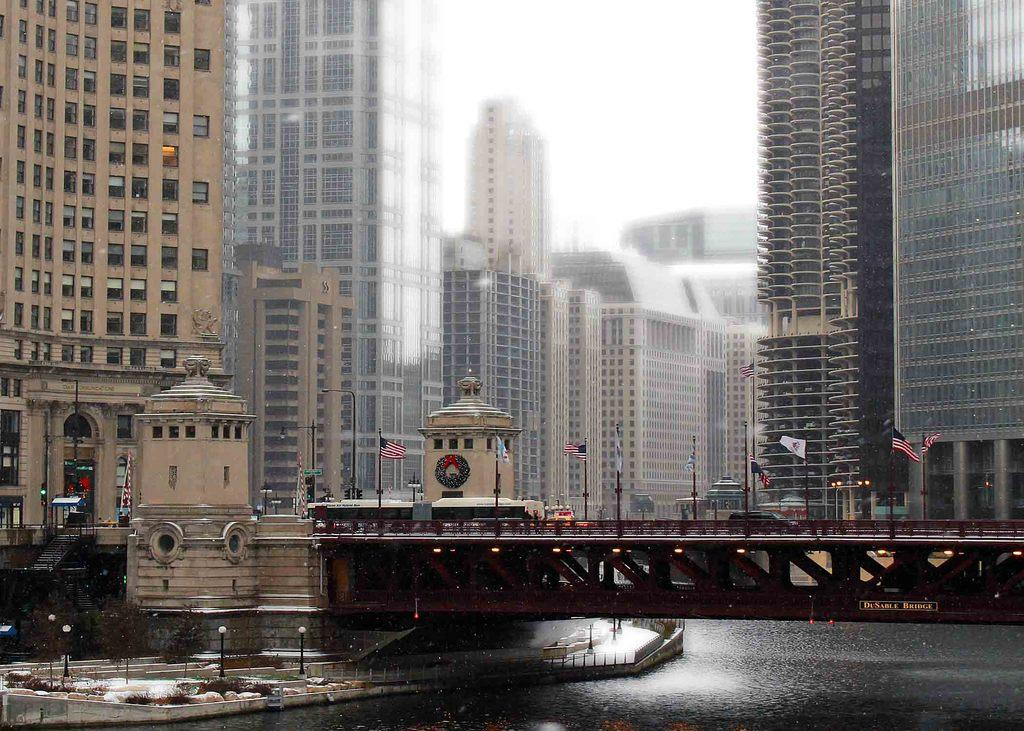What type of structure can be seen in the image? There is a bridgewater in the image. What decorative or symbolic elements are present in the image? There are flags in the image. What type of natural elements can be seen in the image? There are plants in the image. What architectural features are present in the image? There are steps in the image. What type of infrastructure is present in the image? There are traffic signal poles in the image. What type of structures can be seen in the background of the image? There are buildings in the background of the image. What type of openings are visible in the background of the image? There are windows in the background of the image. What type of doors are visible in the background of the image? There are glass doors in the background of the image. What part of the natural environment is visible in the background of the image? The sky is visible in the background of the image. What type of curve can be seen in the thumb of the person in the image? There is no person present in the image, and therefore no thumb or curve can be observed. 